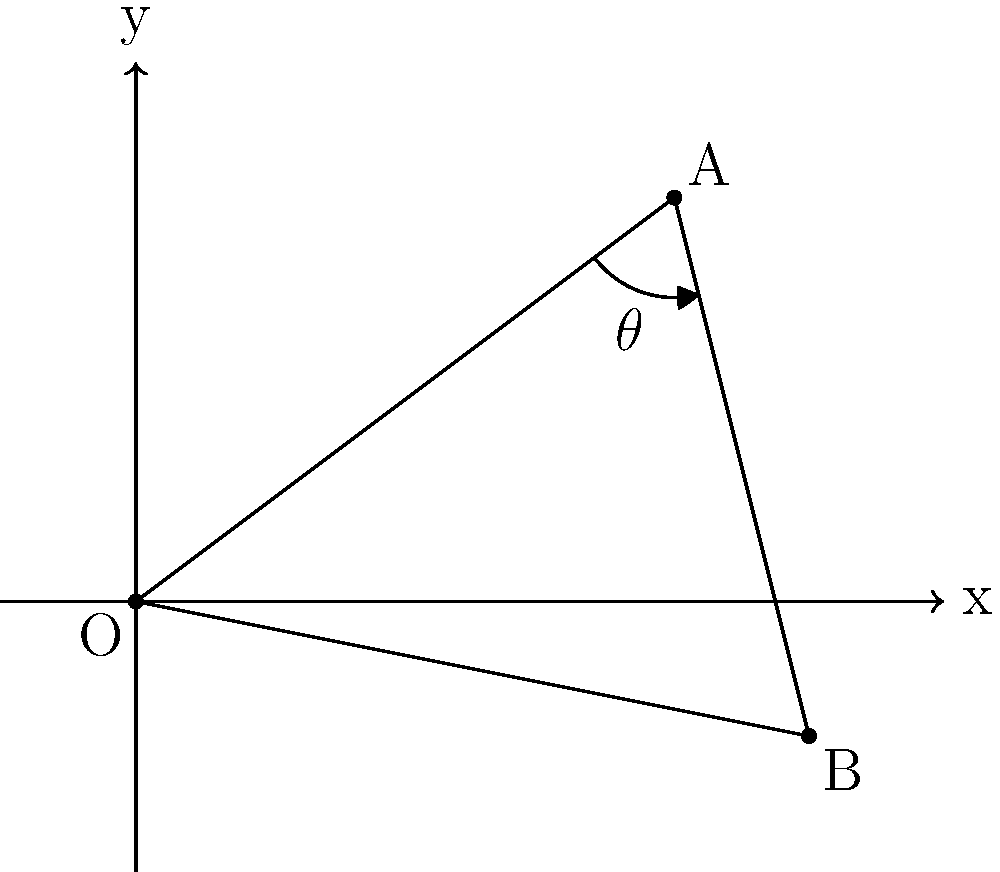In your accounting ledger, two intersecting lines form an angle θ. The coordinates of the points are O(0,0), A(4,3), and B(5,-1). Calculate the measure of angle θ in degrees, rounding your answer to the nearest whole number. To find the angle θ between two intersecting lines OA and OB, we can follow these steps:

1) First, we need to calculate the vectors $\vec{OA}$ and $\vec{OB}$:
   $\vec{OA} = (4-0, 3-0) = (4, 3)$
   $\vec{OB} = (5-0, -1-0) = (5, -1)$

2) The angle between two vectors can be found using the dot product formula:
   $\cos \theta = \frac{\vec{OA} \cdot \vec{OB}}{|\vec{OA}||\vec{OB}|}$

3) Calculate the dot product $\vec{OA} \cdot \vec{OB}$:
   $\vec{OA} \cdot \vec{OB} = 4(5) + 3(-1) = 20 - 3 = 17$

4) Calculate the magnitudes of the vectors:
   $|\vec{OA}| = \sqrt{4^2 + 3^2} = \sqrt{25} = 5$
   $|\vec{OB}| = \sqrt{5^2 + (-1)^2} = \sqrt{26}$

5) Substitute into the formula:
   $\cos \theta = \frac{17}{5\sqrt{26}}$

6) Take the inverse cosine (arccos) of both sides:
   $\theta = \arccos(\frac{17}{5\sqrt{26}})$

7) Convert to degrees and round to the nearest whole number:
   $\theta \approx 44°$
Answer: 44° 